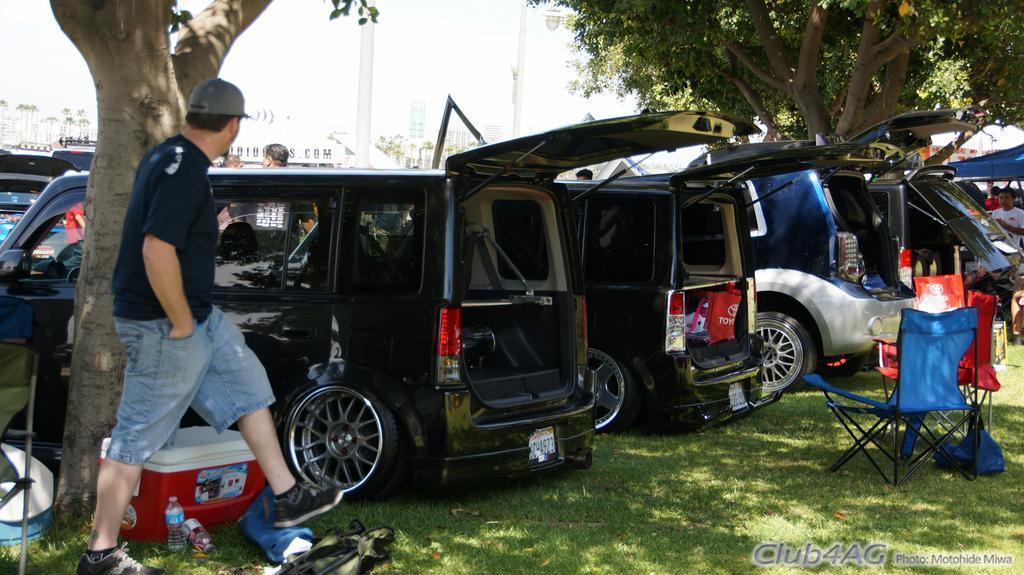Describe this image in one or two sentences. In this picture I can see there is a man walking on to left and there are trees and cars parked at left and there are few chairs, water bottles, boxes placed on the grass and there are few other people in the backdrop and the sky is clear. 